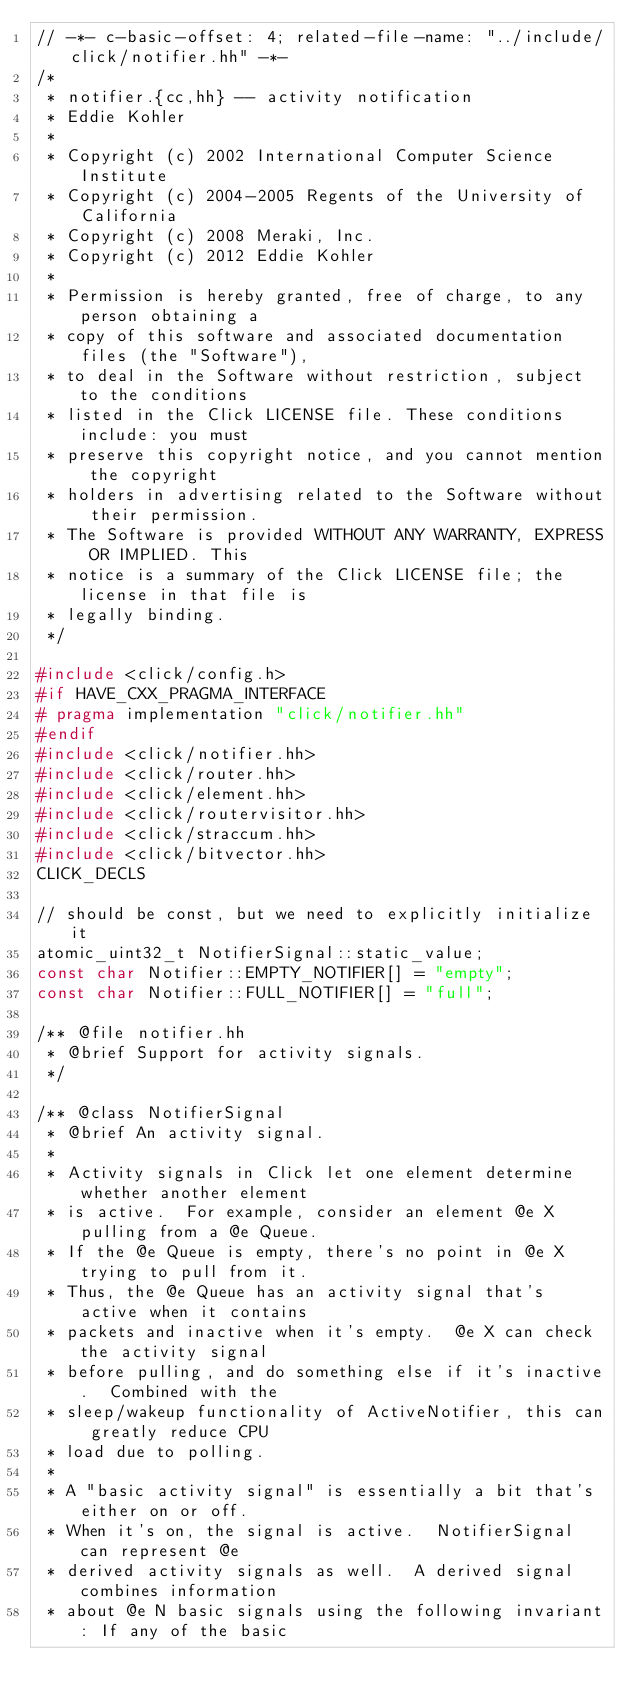<code> <loc_0><loc_0><loc_500><loc_500><_C++_>// -*- c-basic-offset: 4; related-file-name: "../include/click/notifier.hh" -*-
/*
 * notifier.{cc,hh} -- activity notification
 * Eddie Kohler
 *
 * Copyright (c) 2002 International Computer Science Institute
 * Copyright (c) 2004-2005 Regents of the University of California
 * Copyright (c) 2008 Meraki, Inc.
 * Copyright (c) 2012 Eddie Kohler
 *
 * Permission is hereby granted, free of charge, to any person obtaining a
 * copy of this software and associated documentation files (the "Software"),
 * to deal in the Software without restriction, subject to the conditions
 * listed in the Click LICENSE file. These conditions include: you must
 * preserve this copyright notice, and you cannot mention the copyright
 * holders in advertising related to the Software without their permission.
 * The Software is provided WITHOUT ANY WARRANTY, EXPRESS OR IMPLIED. This
 * notice is a summary of the Click LICENSE file; the license in that file is
 * legally binding.
 */

#include <click/config.h>
#if HAVE_CXX_PRAGMA_INTERFACE
# pragma implementation "click/notifier.hh"
#endif
#include <click/notifier.hh>
#include <click/router.hh>
#include <click/element.hh>
#include <click/routervisitor.hh>
#include <click/straccum.hh>
#include <click/bitvector.hh>
CLICK_DECLS

// should be const, but we need to explicitly initialize it
atomic_uint32_t NotifierSignal::static_value;
const char Notifier::EMPTY_NOTIFIER[] = "empty";
const char Notifier::FULL_NOTIFIER[] = "full";

/** @file notifier.hh
 * @brief Support for activity signals.
 */

/** @class NotifierSignal
 * @brief An activity signal.
 *
 * Activity signals in Click let one element determine whether another element
 * is active.  For example, consider an element @e X pulling from a @e Queue.
 * If the @e Queue is empty, there's no point in @e X trying to pull from it.
 * Thus, the @e Queue has an activity signal that's active when it contains
 * packets and inactive when it's empty.  @e X can check the activity signal
 * before pulling, and do something else if it's inactive.  Combined with the
 * sleep/wakeup functionality of ActiveNotifier, this can greatly reduce CPU
 * load due to polling.
 *
 * A "basic activity signal" is essentially a bit that's either on or off.
 * When it's on, the signal is active.  NotifierSignal can represent @e
 * derived activity signals as well.  A derived signal combines information
 * about @e N basic signals using the following invariant: If any of the basic</code> 